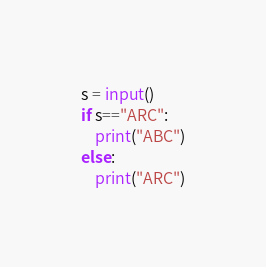<code> <loc_0><loc_0><loc_500><loc_500><_Python_>s = input()
if s=="ARC":
    print("ABC")
else:
    print("ARC")</code> 